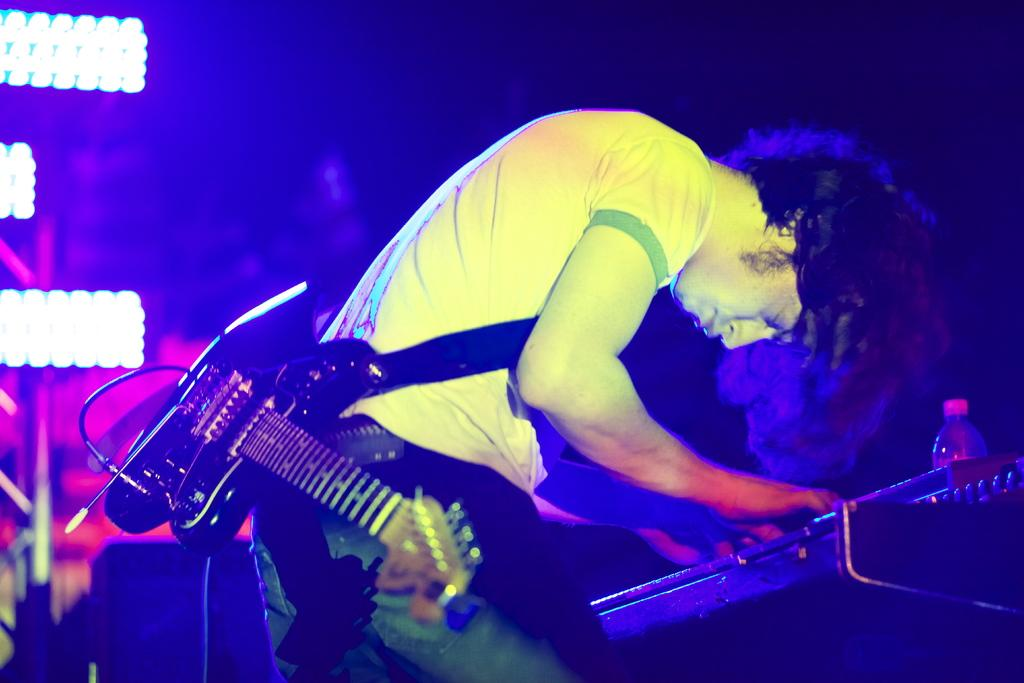What is the man in the image doing? The man is playing a keyboard. What instrument is the man carrying in the image? The man is carrying a guitar. What else can be seen in the image besides the man and his instruments? There is a bottle in the image. What can be seen in the background of the image? There are lights visible in the background of the image. What type of attraction is the man visiting in the image? There is no indication of an attraction in the image; it simply shows a man playing a keyboard and carrying a guitar. What is the man using to stop his vehicle in the image? There is no vehicle or brake present in the image. 